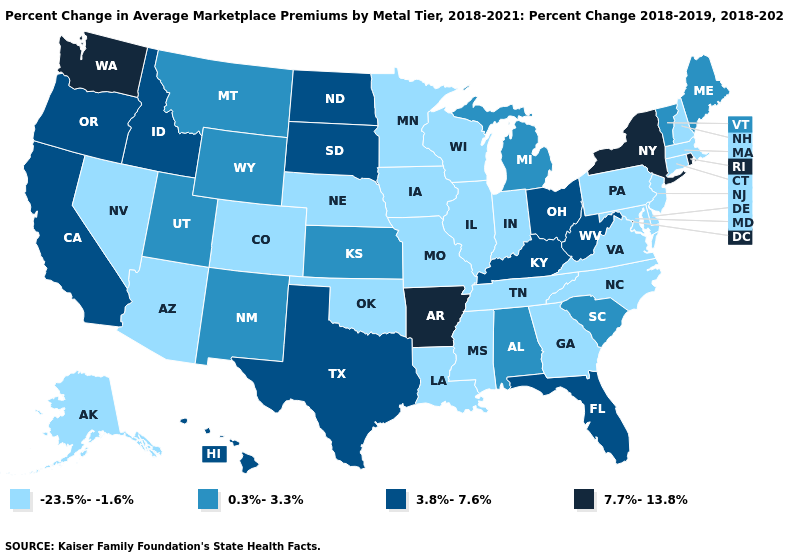What is the lowest value in the Northeast?
Give a very brief answer. -23.5%--1.6%. Name the states that have a value in the range 7.7%-13.8%?
Write a very short answer. Arkansas, New York, Rhode Island, Washington. What is the value of Rhode Island?
Write a very short answer. 7.7%-13.8%. Name the states that have a value in the range 3.8%-7.6%?
Write a very short answer. California, Florida, Hawaii, Idaho, Kentucky, North Dakota, Ohio, Oregon, South Dakota, Texas, West Virginia. What is the highest value in the West ?
Quick response, please. 7.7%-13.8%. What is the value of Maryland?
Keep it brief. -23.5%--1.6%. What is the value of Virginia?
Keep it brief. -23.5%--1.6%. What is the lowest value in states that border North Carolina?
Short answer required. -23.5%--1.6%. Name the states that have a value in the range 3.8%-7.6%?
Concise answer only. California, Florida, Hawaii, Idaho, Kentucky, North Dakota, Ohio, Oregon, South Dakota, Texas, West Virginia. Does the map have missing data?
Answer briefly. No. What is the highest value in states that border Iowa?
Quick response, please. 3.8%-7.6%. How many symbols are there in the legend?
Answer briefly. 4. Name the states that have a value in the range -23.5%--1.6%?
Quick response, please. Alaska, Arizona, Colorado, Connecticut, Delaware, Georgia, Illinois, Indiana, Iowa, Louisiana, Maryland, Massachusetts, Minnesota, Mississippi, Missouri, Nebraska, Nevada, New Hampshire, New Jersey, North Carolina, Oklahoma, Pennsylvania, Tennessee, Virginia, Wisconsin. What is the value of Maine?
Keep it brief. 0.3%-3.3%. 